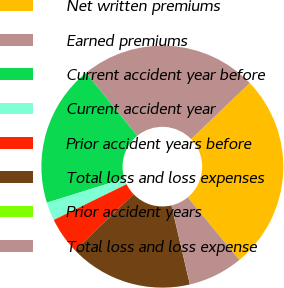<chart> <loc_0><loc_0><loc_500><loc_500><pie_chart><fcel>Net written premiums<fcel>Earned premiums<fcel>Current accident year before<fcel>Current accident year<fcel>Prior accident years before<fcel>Total loss and loss expenses<fcel>Prior accident years<fcel>Total loss and loss expense<nl><fcel>26.16%<fcel>23.73%<fcel>18.94%<fcel>2.45%<fcel>4.89%<fcel>16.5%<fcel>0.01%<fcel>7.32%<nl></chart> 